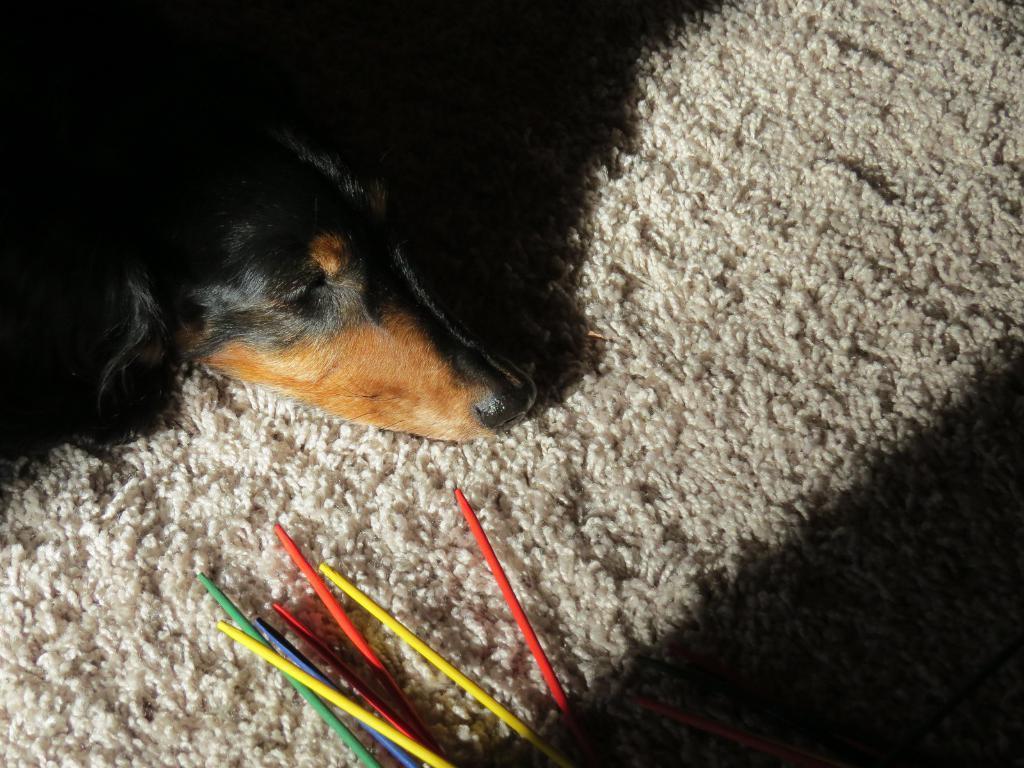Please provide a concise description of this image. In this image we can see a dog, and some stocks on the mat. 